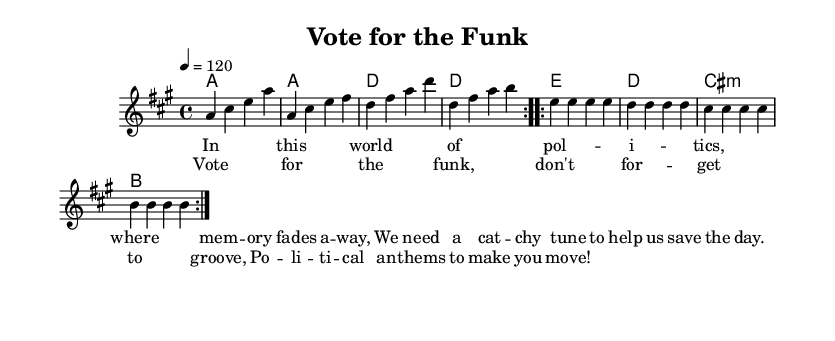What is the key signature of this music? The key signature has three sharps, indicating A major.
Answer: A major What is the time signature of this music? The time signature is indicated by the fraction at the beginning, which is 4/4.
Answer: 4/4 What is the tempo marking of this piece? The tempo marking is shown at the beginning as 4 = 120, indicating the speed.
Answer: 120 How many times is the chorus repeated? The score shows "repeat volta 2" which indicates that the chorus is repeated two times.
Answer: Two times What type of musical form does this piece represent? The piece has verses and a chorus, indicating a verse-chorus structure typical in disco music.
Answer: Verse-chorus What is a prominent theme in the lyrics? The lyrics emphasize political engagement and being active ("Vote for the funk").
Answer: Political engagement What is the primary lyrical structure of the verses? The verses follow a rhyme scheme and use iambic rhythm common in catchy tunes to enhance memorability.
Answer: Rhyme scheme 